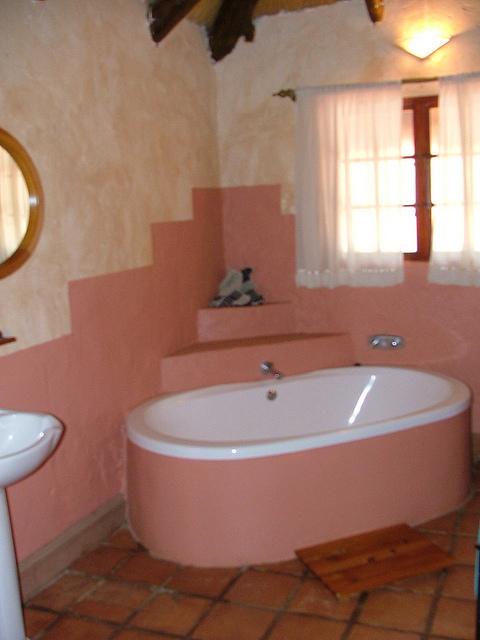Is this a masculine or feminine sort of room?
Be succinct. Feminine. Is there a curtain on the window?
Write a very short answer. Yes. Is the floor dirty?
Write a very short answer. Yes. What is hanging above the bathtub?
Keep it brief. Light. What does the pink paint look like on the wall?
Give a very brief answer. Steps. 